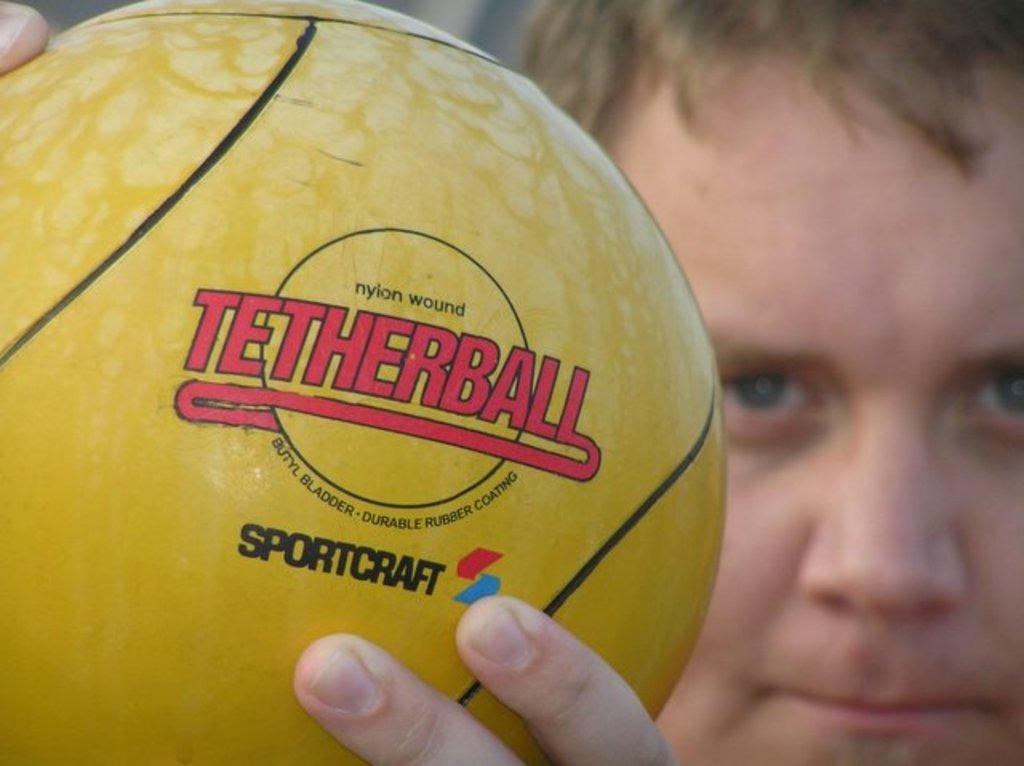<image>
Render a clear and concise summary of the photo. boy holding yellow nylon wound rubber coated tetherball made by sportcraft 